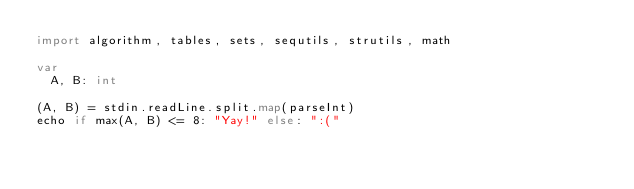<code> <loc_0><loc_0><loc_500><loc_500><_Nim_>import algorithm, tables, sets, sequtils, strutils, math

var
  A, B: int

(A, B) = stdin.readLine.split.map(parseInt)
echo if max(A, B) <= 8: "Yay!" else: ":("</code> 